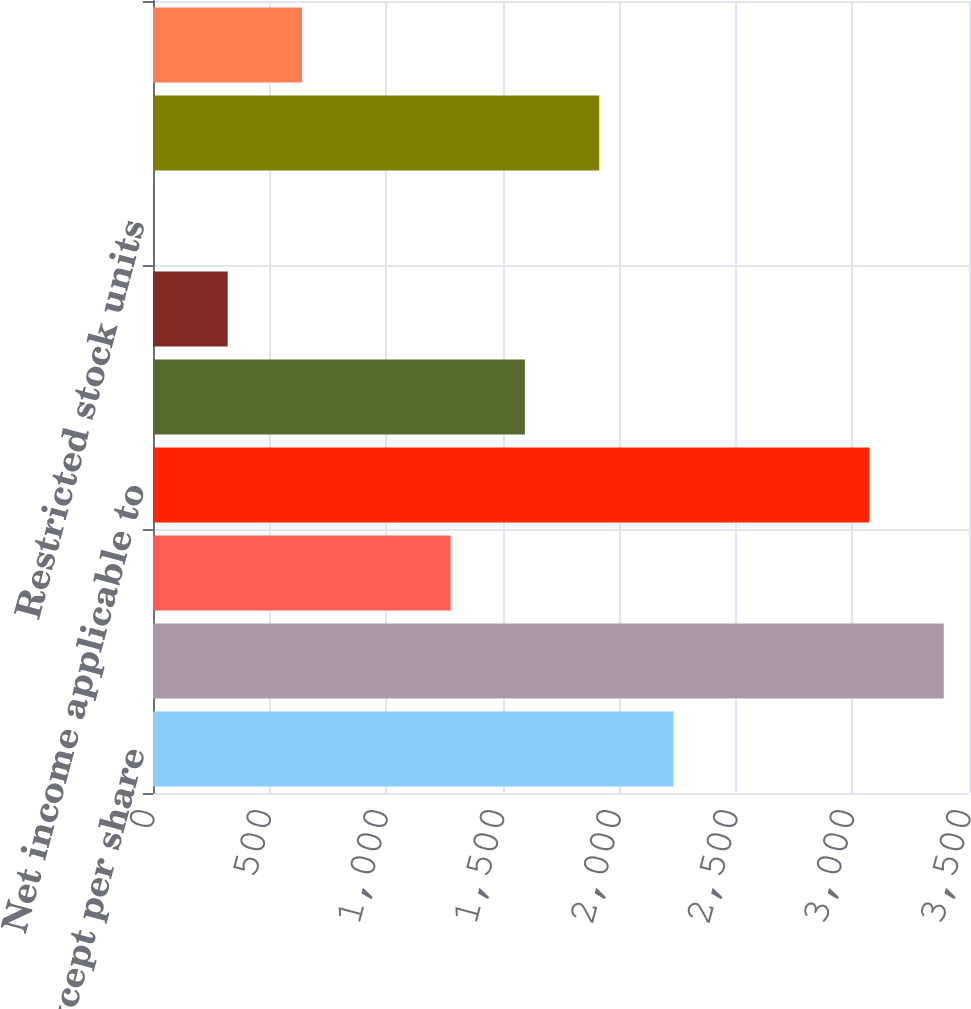Convert chart. <chart><loc_0><loc_0><loc_500><loc_500><bar_chart><fcel>( in millions except per share<fcel>Net income<fcel>Less Preferred stock dividends<fcel>Net income applicable to<fcel>Weighted average common shares<fcel>Stock options<fcel>Restricted stock units<fcel>Weighted average common and<fcel>Earnings per common share -<nl><fcel>2232.75<fcel>3391.75<fcel>1276.5<fcel>3073<fcel>1595.25<fcel>320.25<fcel>1.5<fcel>1914<fcel>639<nl></chart> 